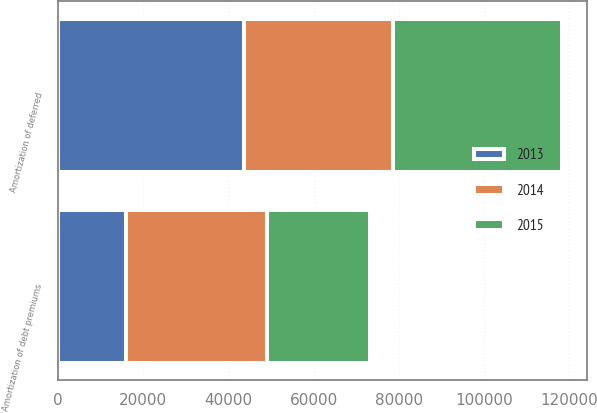Convert chart to OTSL. <chart><loc_0><loc_0><loc_500><loc_500><stacked_bar_chart><ecel><fcel>Amortization of deferred<fcel>Amortization of debt premiums<nl><fcel>2013<fcel>43788<fcel>16107<nl><fcel>2015<fcel>39488<fcel>24092<nl><fcel>2014<fcel>34891<fcel>33026<nl></chart> 